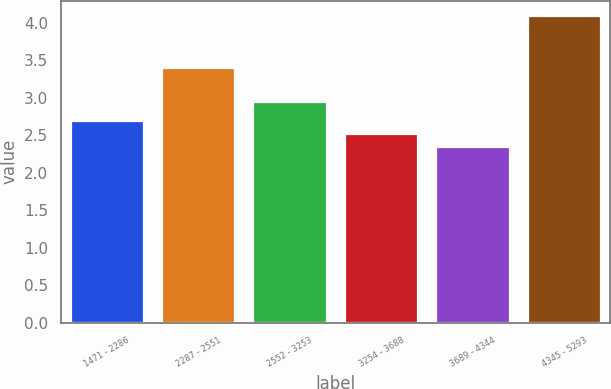<chart> <loc_0><loc_0><loc_500><loc_500><bar_chart><fcel>1471 - 2286<fcel>2287 - 2551<fcel>2552 - 3253<fcel>3254 - 3688<fcel>3689 - 4344<fcel>4345 - 5293<nl><fcel>2.69<fcel>3.4<fcel>2.95<fcel>2.52<fcel>2.35<fcel>4.09<nl></chart> 